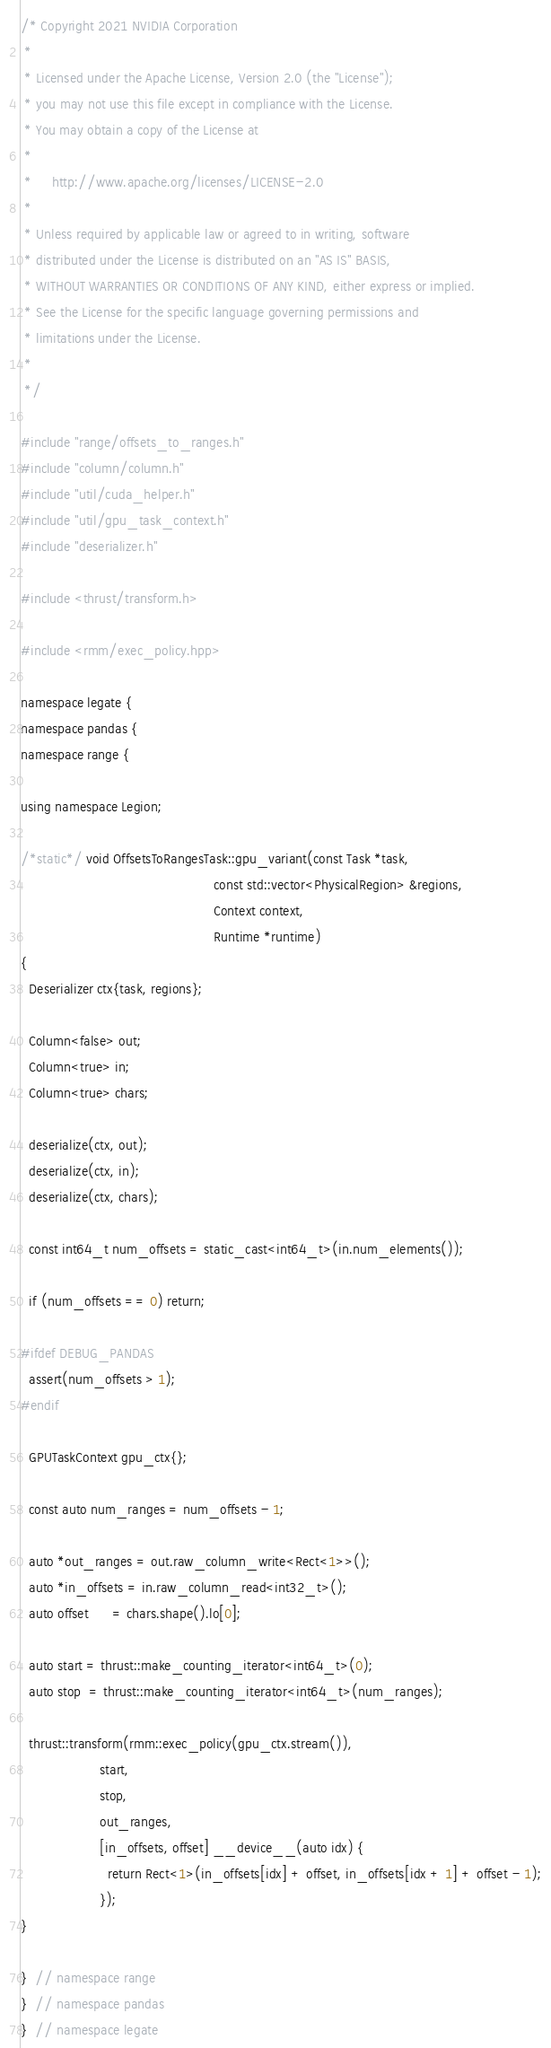Convert code to text. <code><loc_0><loc_0><loc_500><loc_500><_Cuda_>/* Copyright 2021 NVIDIA Corporation
 *
 * Licensed under the Apache License, Version 2.0 (the "License");
 * you may not use this file except in compliance with the License.
 * You may obtain a copy of the License at
 *
 *     http://www.apache.org/licenses/LICENSE-2.0
 *
 * Unless required by applicable law or agreed to in writing, software
 * distributed under the License is distributed on an "AS IS" BASIS,
 * WITHOUT WARRANTIES OR CONDITIONS OF ANY KIND, either express or implied.
 * See the License for the specific language governing permissions and
 * limitations under the License.
 *
 */

#include "range/offsets_to_ranges.h"
#include "column/column.h"
#include "util/cuda_helper.h"
#include "util/gpu_task_context.h"
#include "deserializer.h"

#include <thrust/transform.h>

#include <rmm/exec_policy.hpp>

namespace legate {
namespace pandas {
namespace range {

using namespace Legion;

/*static*/ void OffsetsToRangesTask::gpu_variant(const Task *task,
                                                 const std::vector<PhysicalRegion> &regions,
                                                 Context context,
                                                 Runtime *runtime)
{
  Deserializer ctx{task, regions};

  Column<false> out;
  Column<true> in;
  Column<true> chars;

  deserialize(ctx, out);
  deserialize(ctx, in);
  deserialize(ctx, chars);

  const int64_t num_offsets = static_cast<int64_t>(in.num_elements());

  if (num_offsets == 0) return;

#ifdef DEBUG_PANDAS
  assert(num_offsets > 1);
#endif

  GPUTaskContext gpu_ctx{};

  const auto num_ranges = num_offsets - 1;

  auto *out_ranges = out.raw_column_write<Rect<1>>();
  auto *in_offsets = in.raw_column_read<int32_t>();
  auto offset      = chars.shape().lo[0];

  auto start = thrust::make_counting_iterator<int64_t>(0);
  auto stop  = thrust::make_counting_iterator<int64_t>(num_ranges);

  thrust::transform(rmm::exec_policy(gpu_ctx.stream()),
                    start,
                    stop,
                    out_ranges,
                    [in_offsets, offset] __device__(auto idx) {
                      return Rect<1>(in_offsets[idx] + offset, in_offsets[idx + 1] + offset - 1);
                    });
}

}  // namespace range
}  // namespace pandas
}  // namespace legate
</code> 